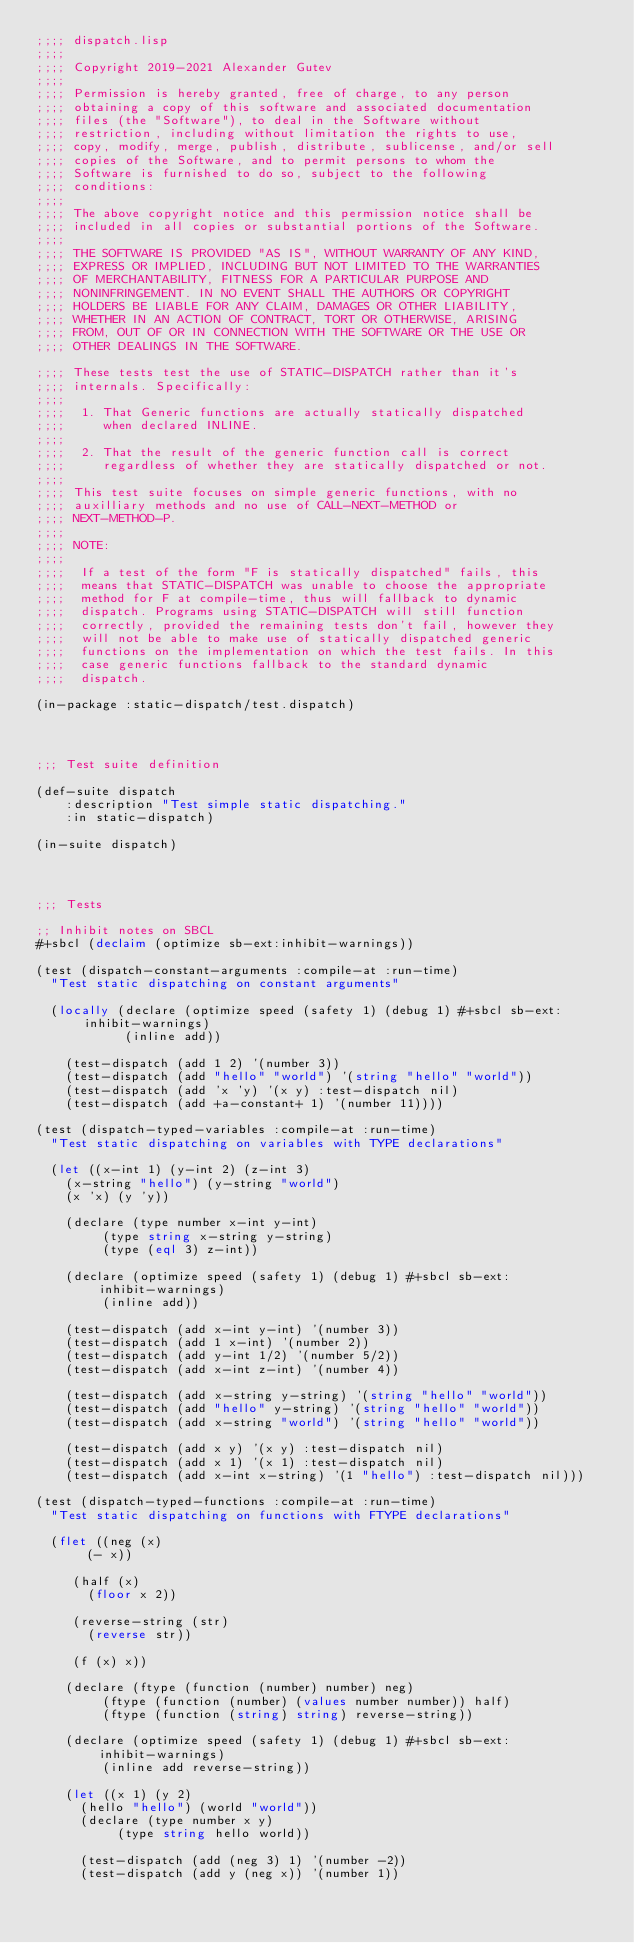Convert code to text. <code><loc_0><loc_0><loc_500><loc_500><_Lisp_>;;;; dispatch.lisp
;;;;
;;;; Copyright 2019-2021 Alexander Gutev
;;;;
;;;; Permission is hereby granted, free of charge, to any person
;;;; obtaining a copy of this software and associated documentation
;;;; files (the "Software"), to deal in the Software without
;;;; restriction, including without limitation the rights to use,
;;;; copy, modify, merge, publish, distribute, sublicense, and/or sell
;;;; copies of the Software, and to permit persons to whom the
;;;; Software is furnished to do so, subject to the following
;;;; conditions:
;;;;
;;;; The above copyright notice and this permission notice shall be
;;;; included in all copies or substantial portions of the Software.
;;;;
;;;; THE SOFTWARE IS PROVIDED "AS IS", WITHOUT WARRANTY OF ANY KIND,
;;;; EXPRESS OR IMPLIED, INCLUDING BUT NOT LIMITED TO THE WARRANTIES
;;;; OF MERCHANTABILITY, FITNESS FOR A PARTICULAR PURPOSE AND
;;;; NONINFRINGEMENT. IN NO EVENT SHALL THE AUTHORS OR COPYRIGHT
;;;; HOLDERS BE LIABLE FOR ANY CLAIM, DAMAGES OR OTHER LIABILITY,
;;;; WHETHER IN AN ACTION OF CONTRACT, TORT OR OTHERWISE, ARISING
;;;; FROM, OUT OF OR IN CONNECTION WITH THE SOFTWARE OR THE USE OR
;;;; OTHER DEALINGS IN THE SOFTWARE.

;;;; These tests test the use of STATIC-DISPATCH rather than it's
;;;; internals. Specifically:
;;;;
;;;;  1. That Generic functions are actually statically dispatched
;;;;     when declared INLINE.
;;;;
;;;;  2. That the result of the generic function call is correct
;;;;     regardless of whether they are statically dispatched or not.
;;;;
;;;; This test suite focuses on simple generic functions, with no
;;;; auxilliary methods and no use of CALL-NEXT-METHOD or
;;;; NEXT-METHOD-P.
;;;;
;;;; NOTE:
;;;;
;;;;  If a test of the form "F is statically dispatched" fails, this
;;;;  means that STATIC-DISPATCH was unable to choose the appropriate
;;;;  method for F at compile-time, thus will fallback to dynamic
;;;;  dispatch. Programs using STATIC-DISPATCH will still function
;;;;  correctly, provided the remaining tests don't fail, however they
;;;;  will not be able to make use of statically dispatched generic
;;;;  functions on the implementation on which the test fails. In this
;;;;  case generic functions fallback to the standard dynamic
;;;;  dispatch.

(in-package :static-dispatch/test.dispatch)


;;; Test suite definition

(def-suite dispatch
    :description "Test simple static dispatching."
    :in static-dispatch)

(in-suite dispatch)


;;; Tests

;; Inhibit notes on SBCL
#+sbcl (declaim (optimize sb-ext:inhibit-warnings))

(test (dispatch-constant-arguments :compile-at :run-time)
  "Test static dispatching on constant arguments"

  (locally (declare (optimize speed (safety 1) (debug 1) #+sbcl sb-ext:inhibit-warnings)
		    (inline add))

    (test-dispatch (add 1 2) '(number 3))
    (test-dispatch (add "hello" "world") '(string "hello" "world"))
    (test-dispatch (add 'x 'y) '(x y) :test-dispatch nil)
    (test-dispatch (add +a-constant+ 1) '(number 11))))

(test (dispatch-typed-variables :compile-at :run-time)
  "Test static dispatching on variables with TYPE declarations"

  (let ((x-int 1) (y-int 2) (z-int 3)
	(x-string "hello") (y-string "world")
	(x 'x) (y 'y))

    (declare (type number x-int y-int)
	     (type string x-string y-string)
	     (type (eql 3) z-int))

    (declare (optimize speed (safety 1) (debug 1) #+sbcl sb-ext:inhibit-warnings)
	     (inline add))

    (test-dispatch (add x-int y-int) '(number 3))
    (test-dispatch (add 1 x-int) '(number 2))
    (test-dispatch (add y-int 1/2) '(number 5/2))
    (test-dispatch (add x-int z-int) '(number 4))

    (test-dispatch (add x-string y-string) '(string "hello" "world"))
    (test-dispatch (add "hello" y-string) '(string "hello" "world"))
    (test-dispatch (add x-string "world") '(string "hello" "world"))

    (test-dispatch (add x y) '(x y) :test-dispatch nil)
    (test-dispatch (add x 1) '(x 1) :test-dispatch nil)
    (test-dispatch (add x-int x-string) '(1 "hello") :test-dispatch nil)))

(test (dispatch-typed-functions :compile-at :run-time)
  "Test static dispatching on functions with FTYPE declarations"

  (flet ((neg (x)
	   (- x))

	 (half (x)
	   (floor x 2))

	 (reverse-string (str)
	   (reverse str))

	 (f (x) x))

    (declare (ftype (function (number) number) neg)
	     (ftype (function (number) (values number number)) half)
	     (ftype (function (string) string) reverse-string))

    (declare (optimize speed (safety 1) (debug 1) #+sbcl sb-ext:inhibit-warnings)
	     (inline add reverse-string))

    (let ((x 1) (y 2)
	  (hello "hello") (world "world"))
      (declare (type number x y)
	       (type string hello world))

      (test-dispatch (add (neg 3) 1) '(number -2))
      (test-dispatch (add y (neg x)) '(number 1))</code> 